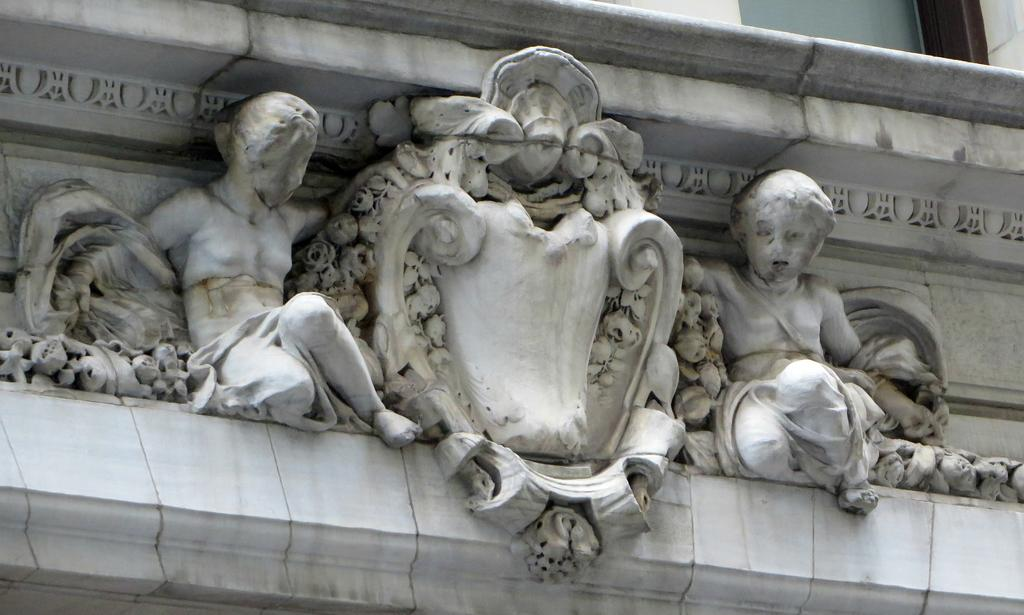What is depicted on the building in the image? There are sculptures on a building in the image. Where are the sculptures located on the building? The sculptures are in the center of the image. What type of cord is being used to support the plants in the image? There are no plants or cords present in the image; it only features sculptures on a building. 